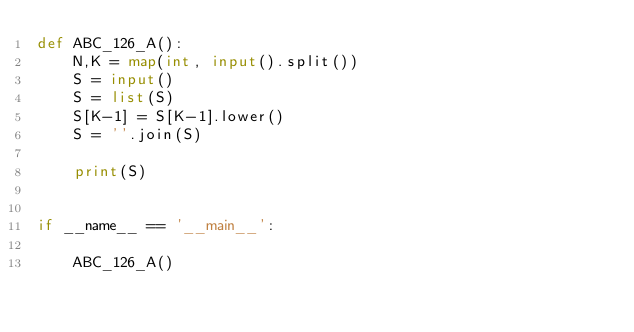Convert code to text. <code><loc_0><loc_0><loc_500><loc_500><_Python_>def ABC_126_A():
    N,K = map(int, input().split())
    S = input()
    S = list(S)
    S[K-1] = S[K-1].lower()
    S = ''.join(S)

    print(S)


if __name__ == '__main__':

    ABC_126_A()</code> 